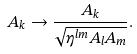<formula> <loc_0><loc_0><loc_500><loc_500>A _ { k } \rightarrow \frac { A _ { k } } { \sqrt { \eta ^ { l m } A _ { l } A _ { m } } } .</formula> 